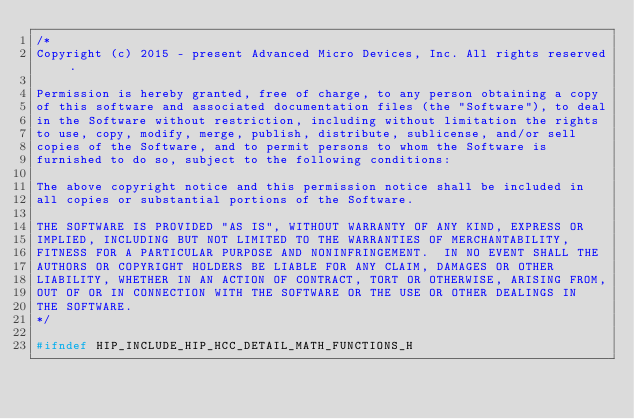<code> <loc_0><loc_0><loc_500><loc_500><_C_>/*
Copyright (c) 2015 - present Advanced Micro Devices, Inc. All rights reserved.

Permission is hereby granted, free of charge, to any person obtaining a copy
of this software and associated documentation files (the "Software"), to deal
in the Software without restriction, including without limitation the rights
to use, copy, modify, merge, publish, distribute, sublicense, and/or sell
copies of the Software, and to permit persons to whom the Software is
furnished to do so, subject to the following conditions:

The above copyright notice and this permission notice shall be included in
all copies or substantial portions of the Software.

THE SOFTWARE IS PROVIDED "AS IS", WITHOUT WARRANTY OF ANY KIND, EXPRESS OR
IMPLIED, INCLUDING BUT NOT LIMITED TO THE WARRANTIES OF MERCHANTABILITY,
FITNESS FOR A PARTICULAR PURPOSE AND NONINFRINGEMENT.  IN NO EVENT SHALL THE
AUTHORS OR COPYRIGHT HOLDERS BE LIABLE FOR ANY CLAIM, DAMAGES OR OTHER
LIABILITY, WHETHER IN AN ACTION OF CONTRACT, TORT OR OTHERWISE, ARISING FROM,
OUT OF OR IN CONNECTION WITH THE SOFTWARE OR THE USE OR OTHER DEALINGS IN
THE SOFTWARE.
*/

#ifndef HIP_INCLUDE_HIP_HCC_DETAIL_MATH_FUNCTIONS_H</code> 